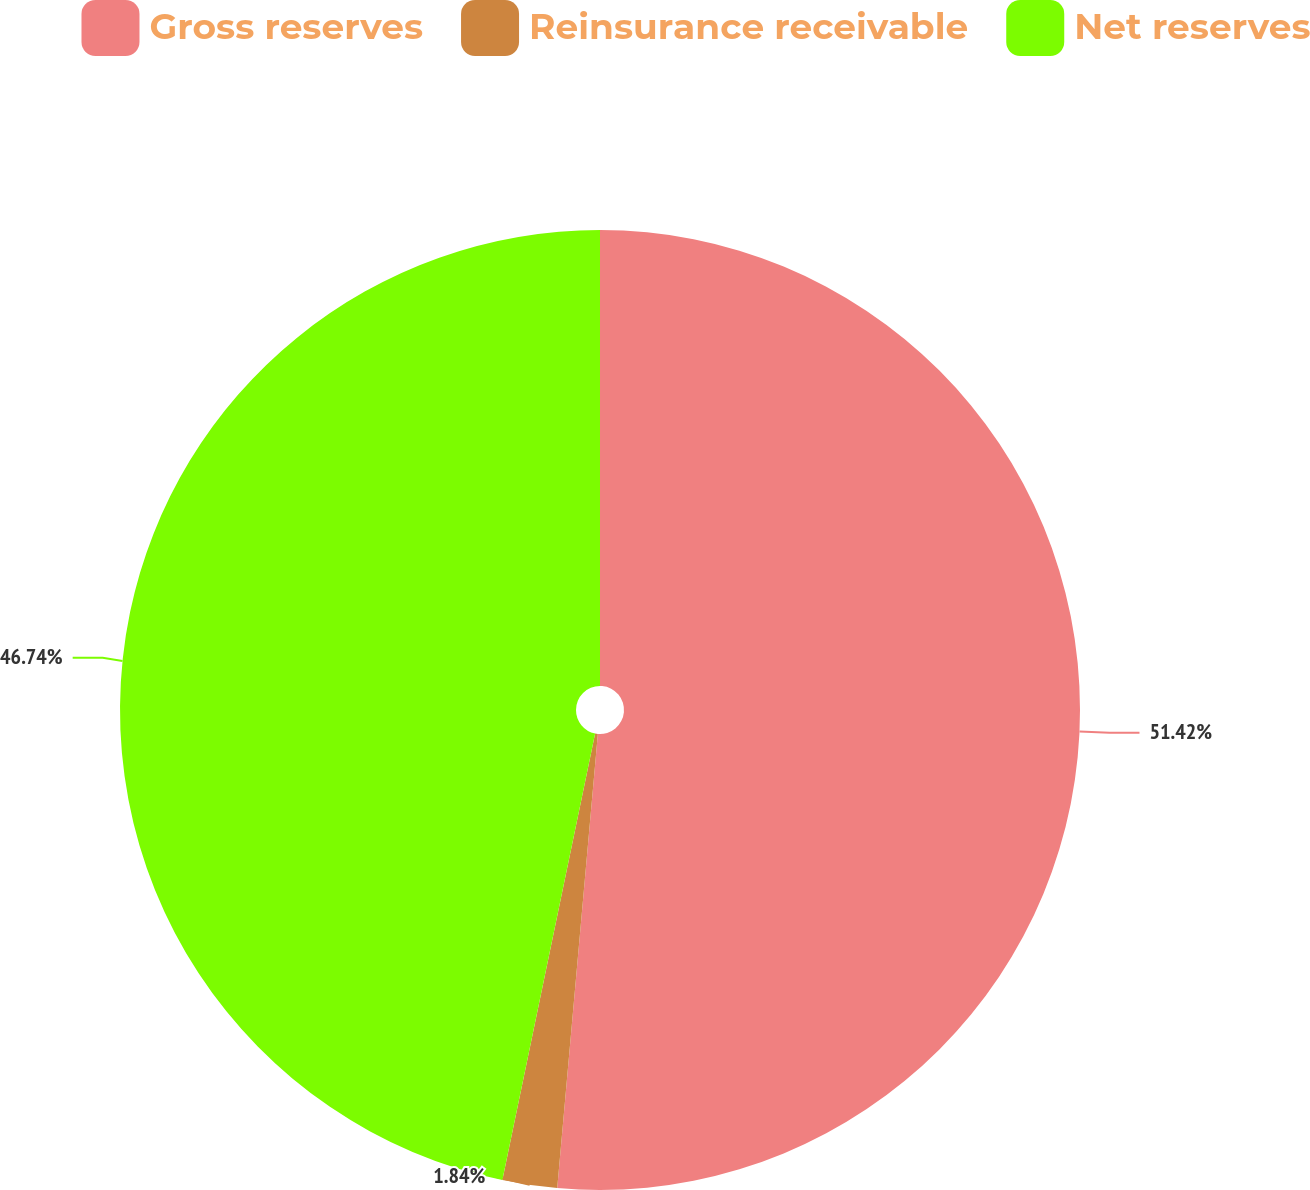<chart> <loc_0><loc_0><loc_500><loc_500><pie_chart><fcel>Gross reserves<fcel>Reinsurance receivable<fcel>Net reserves<nl><fcel>51.42%<fcel>1.84%<fcel>46.74%<nl></chart> 